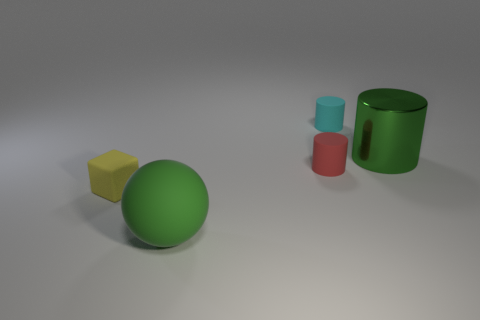Subtract all tiny cylinders. How many cylinders are left? 1 Add 2 gray blocks. How many objects exist? 7 Subtract all cylinders. How many objects are left? 2 Subtract all large metallic cylinders. Subtract all small cylinders. How many objects are left? 2 Add 3 green things. How many green things are left? 5 Add 5 tiny red rubber cylinders. How many tiny red rubber cylinders exist? 6 Subtract 0 purple spheres. How many objects are left? 5 